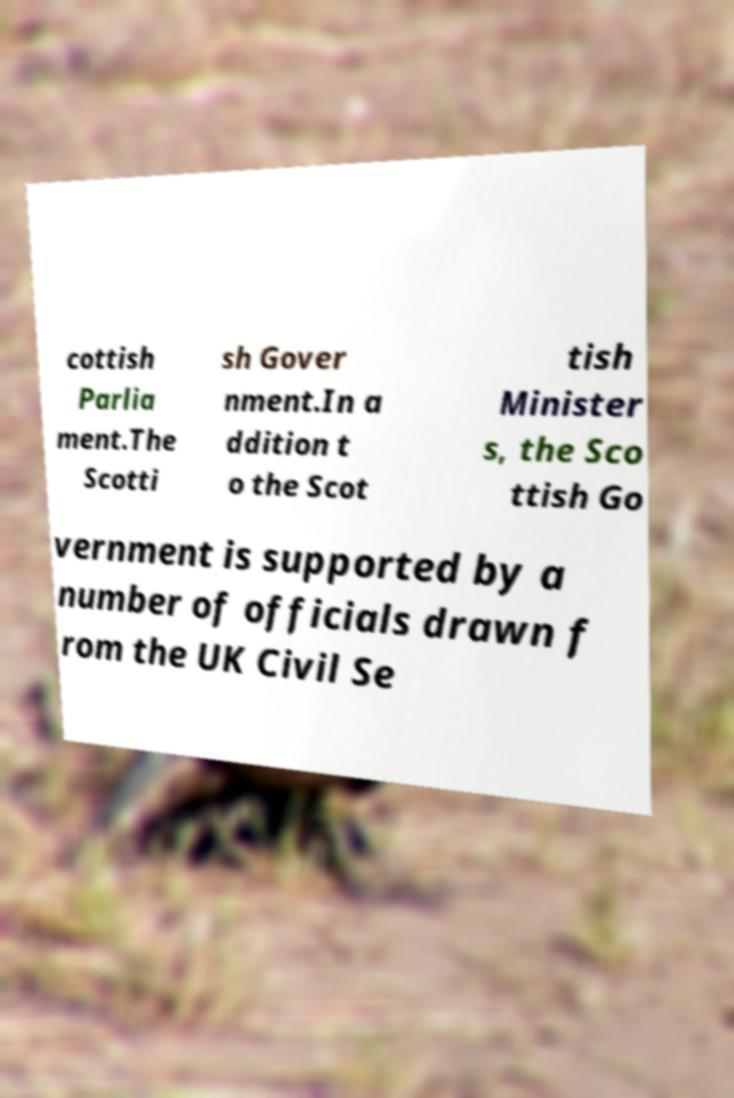What messages or text are displayed in this image? I need them in a readable, typed format. cottish Parlia ment.The Scotti sh Gover nment.In a ddition t o the Scot tish Minister s, the Sco ttish Go vernment is supported by a number of officials drawn f rom the UK Civil Se 